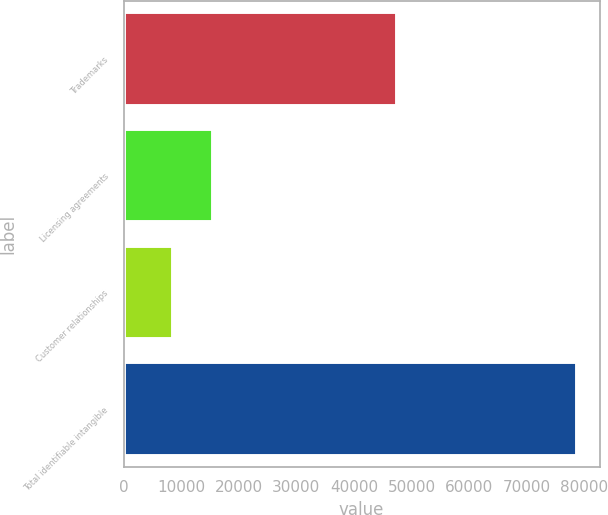Convert chart to OTSL. <chart><loc_0><loc_0><loc_500><loc_500><bar_chart><fcel>Trademarks<fcel>Licensing agreements<fcel>Customer relationships<fcel>Total identifiable intangible<nl><fcel>47509<fcel>15601.7<fcel>8586<fcel>78743<nl></chart> 